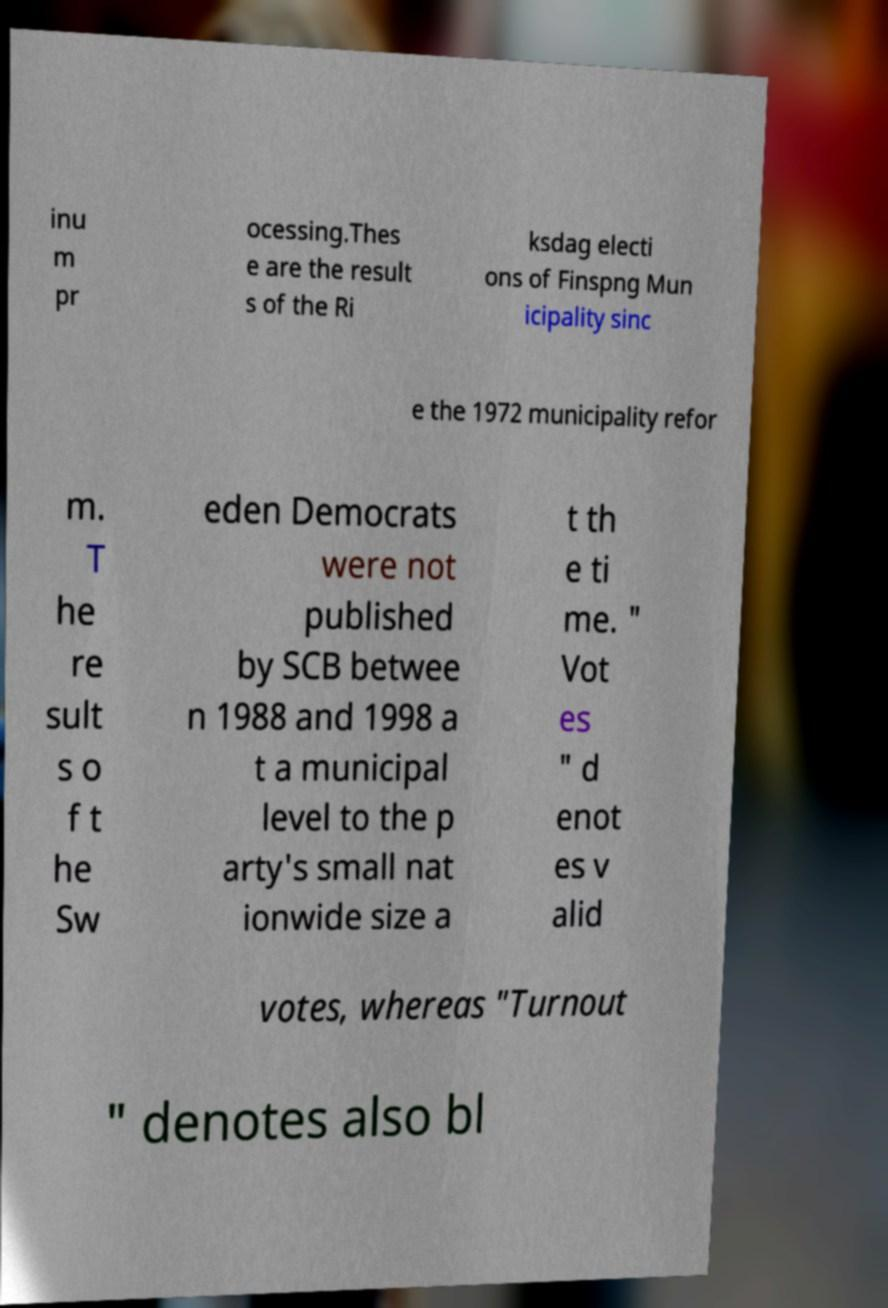What messages or text are displayed in this image? I need them in a readable, typed format. inu m pr ocessing.Thes e are the result s of the Ri ksdag electi ons of Finspng Mun icipality sinc e the 1972 municipality refor m. T he re sult s o f t he Sw eden Democrats were not published by SCB betwee n 1988 and 1998 a t a municipal level to the p arty's small nat ionwide size a t th e ti me. " Vot es " d enot es v alid votes, whereas "Turnout " denotes also bl 